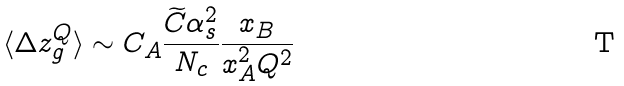Convert formula to latex. <formula><loc_0><loc_0><loc_500><loc_500>\langle \Delta z _ { g } ^ { Q } \rangle \sim C _ { A } \frac { \widetilde { C } \alpha _ { s } ^ { 2 } } { N _ { c } } \frac { x _ { B } } { x _ { A } ^ { 2 } Q ^ { 2 } }</formula> 